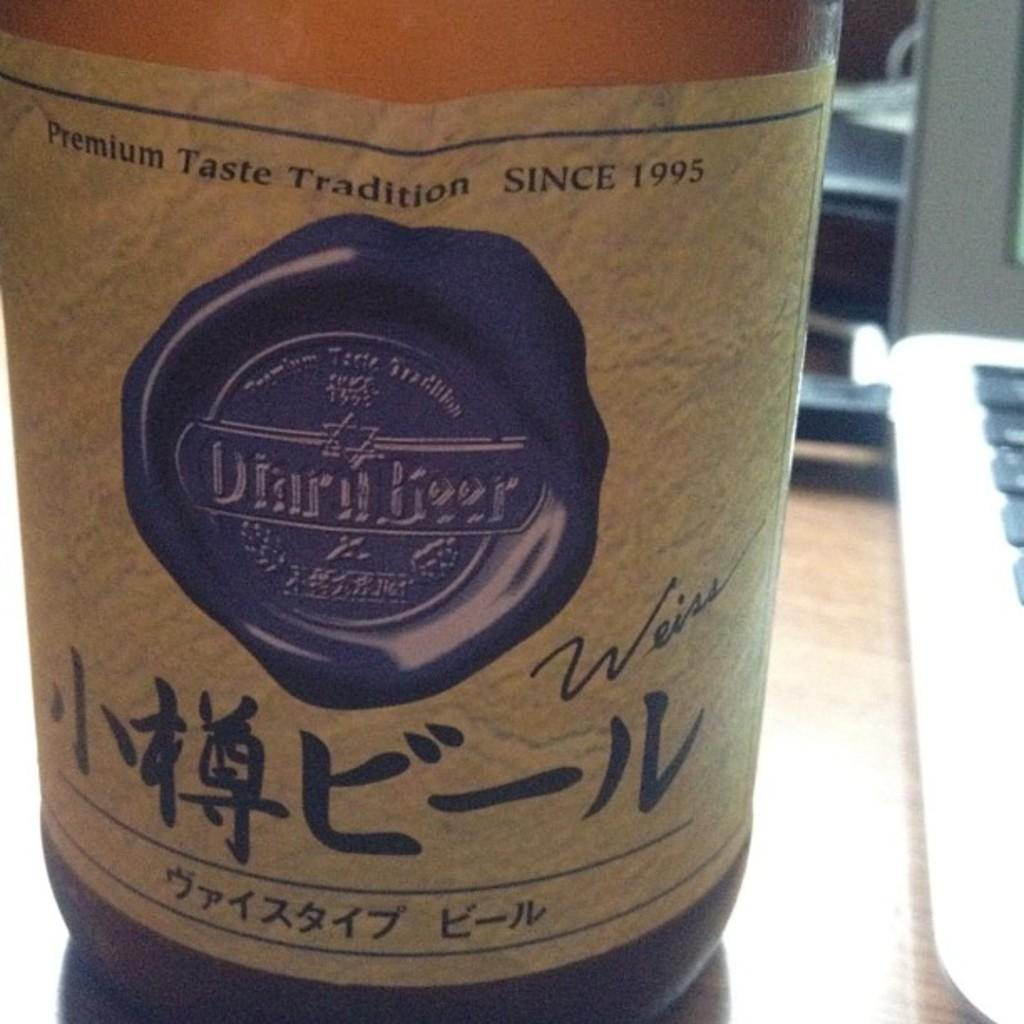<image>
Present a compact description of the photo's key features. A bottle of beer says that it has had premium taste tradition since 1995. 